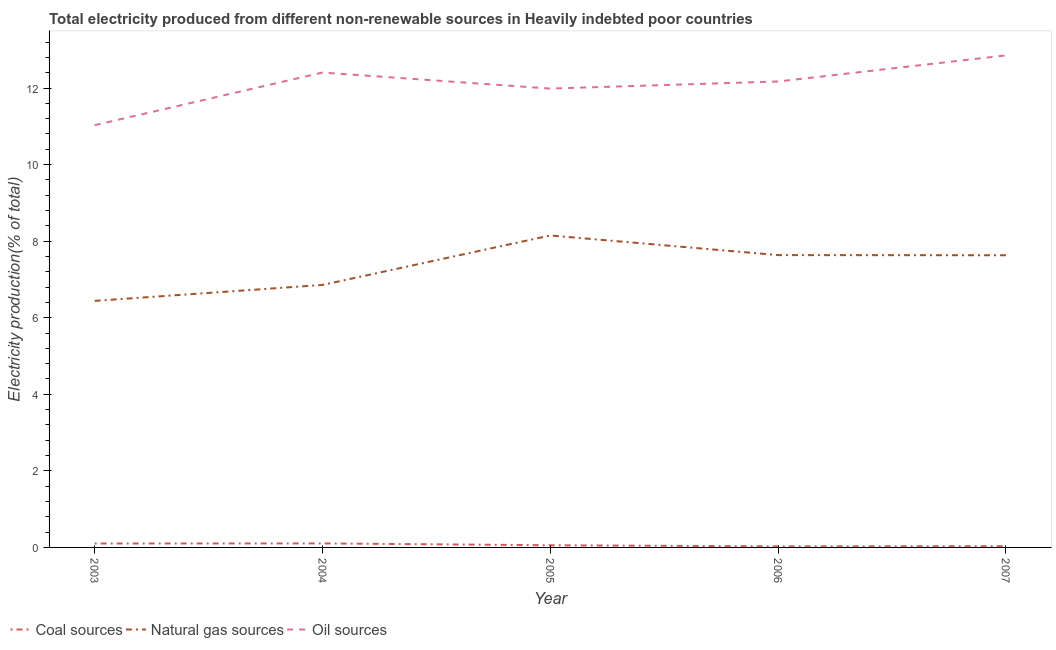What is the percentage of electricity produced by oil sources in 2004?
Give a very brief answer. 12.4. Across all years, what is the maximum percentage of electricity produced by oil sources?
Give a very brief answer. 12.85. Across all years, what is the minimum percentage of electricity produced by oil sources?
Provide a succinct answer. 11.03. In which year was the percentage of electricity produced by coal maximum?
Keep it short and to the point. 2004. In which year was the percentage of electricity produced by coal minimum?
Your response must be concise. 2006. What is the total percentage of electricity produced by coal in the graph?
Offer a terse response. 0.32. What is the difference between the percentage of electricity produced by coal in 2004 and that in 2007?
Offer a terse response. 0.07. What is the difference between the percentage of electricity produced by oil sources in 2007 and the percentage of electricity produced by natural gas in 2006?
Your response must be concise. 5.22. What is the average percentage of electricity produced by natural gas per year?
Your answer should be compact. 7.34. In the year 2006, what is the difference between the percentage of electricity produced by natural gas and percentage of electricity produced by oil sources?
Provide a short and direct response. -4.53. In how many years, is the percentage of electricity produced by coal greater than 9.2 %?
Offer a terse response. 0. What is the ratio of the percentage of electricity produced by natural gas in 2005 to that in 2007?
Provide a short and direct response. 1.07. What is the difference between the highest and the second highest percentage of electricity produced by coal?
Keep it short and to the point. 0. What is the difference between the highest and the lowest percentage of electricity produced by oil sources?
Provide a short and direct response. 1.82. Is the sum of the percentage of electricity produced by coal in 2003 and 2006 greater than the maximum percentage of electricity produced by oil sources across all years?
Give a very brief answer. No. Is it the case that in every year, the sum of the percentage of electricity produced by coal and percentage of electricity produced by natural gas is greater than the percentage of electricity produced by oil sources?
Your answer should be very brief. No. Does the percentage of electricity produced by natural gas monotonically increase over the years?
Your response must be concise. No. How many years are there in the graph?
Provide a succinct answer. 5. Are the values on the major ticks of Y-axis written in scientific E-notation?
Keep it short and to the point. No. Where does the legend appear in the graph?
Your response must be concise. Bottom left. How many legend labels are there?
Offer a very short reply. 3. What is the title of the graph?
Your response must be concise. Total electricity produced from different non-renewable sources in Heavily indebted poor countries. Does "Unpaid family workers" appear as one of the legend labels in the graph?
Your response must be concise. No. What is the Electricity production(% of total) of Coal sources in 2003?
Your answer should be compact. 0.1. What is the Electricity production(% of total) of Natural gas sources in 2003?
Provide a short and direct response. 6.44. What is the Electricity production(% of total) in Oil sources in 2003?
Provide a short and direct response. 11.03. What is the Electricity production(% of total) in Coal sources in 2004?
Provide a short and direct response. 0.11. What is the Electricity production(% of total) in Natural gas sources in 2004?
Offer a very short reply. 6.86. What is the Electricity production(% of total) in Oil sources in 2004?
Provide a succinct answer. 12.4. What is the Electricity production(% of total) of Coal sources in 2005?
Provide a short and direct response. 0.06. What is the Electricity production(% of total) of Natural gas sources in 2005?
Ensure brevity in your answer.  8.15. What is the Electricity production(% of total) of Oil sources in 2005?
Ensure brevity in your answer.  11.98. What is the Electricity production(% of total) in Coal sources in 2006?
Your answer should be very brief. 0.03. What is the Electricity production(% of total) of Natural gas sources in 2006?
Offer a very short reply. 7.64. What is the Electricity production(% of total) of Oil sources in 2006?
Offer a very short reply. 12.17. What is the Electricity production(% of total) of Coal sources in 2007?
Make the answer very short. 0.03. What is the Electricity production(% of total) in Natural gas sources in 2007?
Your response must be concise. 7.63. What is the Electricity production(% of total) of Oil sources in 2007?
Provide a short and direct response. 12.85. Across all years, what is the maximum Electricity production(% of total) of Coal sources?
Offer a very short reply. 0.11. Across all years, what is the maximum Electricity production(% of total) of Natural gas sources?
Your answer should be compact. 8.15. Across all years, what is the maximum Electricity production(% of total) of Oil sources?
Your response must be concise. 12.85. Across all years, what is the minimum Electricity production(% of total) in Coal sources?
Offer a very short reply. 0.03. Across all years, what is the minimum Electricity production(% of total) of Natural gas sources?
Offer a terse response. 6.44. Across all years, what is the minimum Electricity production(% of total) in Oil sources?
Give a very brief answer. 11.03. What is the total Electricity production(% of total) of Coal sources in the graph?
Provide a succinct answer. 0.32. What is the total Electricity production(% of total) of Natural gas sources in the graph?
Your answer should be very brief. 36.71. What is the total Electricity production(% of total) in Oil sources in the graph?
Offer a terse response. 60.44. What is the difference between the Electricity production(% of total) of Coal sources in 2003 and that in 2004?
Ensure brevity in your answer.  -0. What is the difference between the Electricity production(% of total) of Natural gas sources in 2003 and that in 2004?
Your answer should be very brief. -0.42. What is the difference between the Electricity production(% of total) in Oil sources in 2003 and that in 2004?
Provide a succinct answer. -1.38. What is the difference between the Electricity production(% of total) in Coal sources in 2003 and that in 2005?
Provide a succinct answer. 0.05. What is the difference between the Electricity production(% of total) in Natural gas sources in 2003 and that in 2005?
Provide a succinct answer. -1.71. What is the difference between the Electricity production(% of total) in Oil sources in 2003 and that in 2005?
Make the answer very short. -0.96. What is the difference between the Electricity production(% of total) in Coal sources in 2003 and that in 2006?
Your answer should be very brief. 0.07. What is the difference between the Electricity production(% of total) in Natural gas sources in 2003 and that in 2006?
Ensure brevity in your answer.  -1.2. What is the difference between the Electricity production(% of total) in Oil sources in 2003 and that in 2006?
Keep it short and to the point. -1.14. What is the difference between the Electricity production(% of total) of Coal sources in 2003 and that in 2007?
Your response must be concise. 0.07. What is the difference between the Electricity production(% of total) of Natural gas sources in 2003 and that in 2007?
Keep it short and to the point. -1.19. What is the difference between the Electricity production(% of total) in Oil sources in 2003 and that in 2007?
Your answer should be compact. -1.82. What is the difference between the Electricity production(% of total) of Coal sources in 2004 and that in 2005?
Keep it short and to the point. 0.05. What is the difference between the Electricity production(% of total) of Natural gas sources in 2004 and that in 2005?
Provide a short and direct response. -1.29. What is the difference between the Electricity production(% of total) of Oil sources in 2004 and that in 2005?
Your answer should be compact. 0.42. What is the difference between the Electricity production(% of total) of Coal sources in 2004 and that in 2006?
Your response must be concise. 0.08. What is the difference between the Electricity production(% of total) of Natural gas sources in 2004 and that in 2006?
Make the answer very short. -0.78. What is the difference between the Electricity production(% of total) of Oil sources in 2004 and that in 2006?
Your response must be concise. 0.23. What is the difference between the Electricity production(% of total) of Coal sources in 2004 and that in 2007?
Make the answer very short. 0.07. What is the difference between the Electricity production(% of total) of Natural gas sources in 2004 and that in 2007?
Your response must be concise. -0.78. What is the difference between the Electricity production(% of total) of Oil sources in 2004 and that in 2007?
Keep it short and to the point. -0.45. What is the difference between the Electricity production(% of total) of Coal sources in 2005 and that in 2006?
Offer a very short reply. 0.03. What is the difference between the Electricity production(% of total) of Natural gas sources in 2005 and that in 2006?
Your answer should be compact. 0.51. What is the difference between the Electricity production(% of total) in Oil sources in 2005 and that in 2006?
Your answer should be very brief. -0.19. What is the difference between the Electricity production(% of total) of Coal sources in 2005 and that in 2007?
Provide a short and direct response. 0.02. What is the difference between the Electricity production(% of total) of Natural gas sources in 2005 and that in 2007?
Provide a short and direct response. 0.52. What is the difference between the Electricity production(% of total) in Oil sources in 2005 and that in 2007?
Ensure brevity in your answer.  -0.87. What is the difference between the Electricity production(% of total) in Coal sources in 2006 and that in 2007?
Keep it short and to the point. -0. What is the difference between the Electricity production(% of total) of Natural gas sources in 2006 and that in 2007?
Keep it short and to the point. 0. What is the difference between the Electricity production(% of total) in Oil sources in 2006 and that in 2007?
Your response must be concise. -0.68. What is the difference between the Electricity production(% of total) of Coal sources in 2003 and the Electricity production(% of total) of Natural gas sources in 2004?
Provide a succinct answer. -6.75. What is the difference between the Electricity production(% of total) in Coal sources in 2003 and the Electricity production(% of total) in Oil sources in 2004?
Your answer should be compact. -12.3. What is the difference between the Electricity production(% of total) of Natural gas sources in 2003 and the Electricity production(% of total) of Oil sources in 2004?
Give a very brief answer. -5.96. What is the difference between the Electricity production(% of total) of Coal sources in 2003 and the Electricity production(% of total) of Natural gas sources in 2005?
Provide a succinct answer. -8.05. What is the difference between the Electricity production(% of total) in Coal sources in 2003 and the Electricity production(% of total) in Oil sources in 2005?
Offer a terse response. -11.88. What is the difference between the Electricity production(% of total) of Natural gas sources in 2003 and the Electricity production(% of total) of Oil sources in 2005?
Your answer should be compact. -5.55. What is the difference between the Electricity production(% of total) of Coal sources in 2003 and the Electricity production(% of total) of Natural gas sources in 2006?
Give a very brief answer. -7.53. What is the difference between the Electricity production(% of total) in Coal sources in 2003 and the Electricity production(% of total) in Oil sources in 2006?
Offer a terse response. -12.07. What is the difference between the Electricity production(% of total) of Natural gas sources in 2003 and the Electricity production(% of total) of Oil sources in 2006?
Keep it short and to the point. -5.73. What is the difference between the Electricity production(% of total) of Coal sources in 2003 and the Electricity production(% of total) of Natural gas sources in 2007?
Offer a terse response. -7.53. What is the difference between the Electricity production(% of total) in Coal sources in 2003 and the Electricity production(% of total) in Oil sources in 2007?
Ensure brevity in your answer.  -12.75. What is the difference between the Electricity production(% of total) of Natural gas sources in 2003 and the Electricity production(% of total) of Oil sources in 2007?
Keep it short and to the point. -6.41. What is the difference between the Electricity production(% of total) in Coal sources in 2004 and the Electricity production(% of total) in Natural gas sources in 2005?
Provide a short and direct response. -8.04. What is the difference between the Electricity production(% of total) of Coal sources in 2004 and the Electricity production(% of total) of Oil sources in 2005?
Offer a very short reply. -11.88. What is the difference between the Electricity production(% of total) of Natural gas sources in 2004 and the Electricity production(% of total) of Oil sources in 2005?
Give a very brief answer. -5.13. What is the difference between the Electricity production(% of total) of Coal sources in 2004 and the Electricity production(% of total) of Natural gas sources in 2006?
Your response must be concise. -7.53. What is the difference between the Electricity production(% of total) of Coal sources in 2004 and the Electricity production(% of total) of Oil sources in 2006?
Offer a very short reply. -12.07. What is the difference between the Electricity production(% of total) of Natural gas sources in 2004 and the Electricity production(% of total) of Oil sources in 2006?
Make the answer very short. -5.31. What is the difference between the Electricity production(% of total) in Coal sources in 2004 and the Electricity production(% of total) in Natural gas sources in 2007?
Offer a terse response. -7.53. What is the difference between the Electricity production(% of total) of Coal sources in 2004 and the Electricity production(% of total) of Oil sources in 2007?
Your answer should be very brief. -12.75. What is the difference between the Electricity production(% of total) of Natural gas sources in 2004 and the Electricity production(% of total) of Oil sources in 2007?
Provide a short and direct response. -6. What is the difference between the Electricity production(% of total) of Coal sources in 2005 and the Electricity production(% of total) of Natural gas sources in 2006?
Ensure brevity in your answer.  -7.58. What is the difference between the Electricity production(% of total) in Coal sources in 2005 and the Electricity production(% of total) in Oil sources in 2006?
Provide a succinct answer. -12.11. What is the difference between the Electricity production(% of total) in Natural gas sources in 2005 and the Electricity production(% of total) in Oil sources in 2006?
Provide a succinct answer. -4.02. What is the difference between the Electricity production(% of total) in Coal sources in 2005 and the Electricity production(% of total) in Natural gas sources in 2007?
Give a very brief answer. -7.58. What is the difference between the Electricity production(% of total) of Coal sources in 2005 and the Electricity production(% of total) of Oil sources in 2007?
Provide a succinct answer. -12.8. What is the difference between the Electricity production(% of total) in Natural gas sources in 2005 and the Electricity production(% of total) in Oil sources in 2007?
Provide a short and direct response. -4.7. What is the difference between the Electricity production(% of total) in Coal sources in 2006 and the Electricity production(% of total) in Natural gas sources in 2007?
Provide a succinct answer. -7.6. What is the difference between the Electricity production(% of total) of Coal sources in 2006 and the Electricity production(% of total) of Oil sources in 2007?
Your answer should be very brief. -12.82. What is the difference between the Electricity production(% of total) of Natural gas sources in 2006 and the Electricity production(% of total) of Oil sources in 2007?
Offer a terse response. -5.22. What is the average Electricity production(% of total) in Coal sources per year?
Your answer should be very brief. 0.06. What is the average Electricity production(% of total) of Natural gas sources per year?
Your answer should be compact. 7.34. What is the average Electricity production(% of total) of Oil sources per year?
Make the answer very short. 12.09. In the year 2003, what is the difference between the Electricity production(% of total) in Coal sources and Electricity production(% of total) in Natural gas sources?
Make the answer very short. -6.34. In the year 2003, what is the difference between the Electricity production(% of total) in Coal sources and Electricity production(% of total) in Oil sources?
Your response must be concise. -10.93. In the year 2003, what is the difference between the Electricity production(% of total) in Natural gas sources and Electricity production(% of total) in Oil sources?
Offer a terse response. -4.59. In the year 2004, what is the difference between the Electricity production(% of total) of Coal sources and Electricity production(% of total) of Natural gas sources?
Offer a terse response. -6.75. In the year 2004, what is the difference between the Electricity production(% of total) of Coal sources and Electricity production(% of total) of Oil sources?
Keep it short and to the point. -12.3. In the year 2004, what is the difference between the Electricity production(% of total) of Natural gas sources and Electricity production(% of total) of Oil sources?
Offer a very short reply. -5.55. In the year 2005, what is the difference between the Electricity production(% of total) of Coal sources and Electricity production(% of total) of Natural gas sources?
Make the answer very short. -8.09. In the year 2005, what is the difference between the Electricity production(% of total) in Coal sources and Electricity production(% of total) in Oil sources?
Ensure brevity in your answer.  -11.93. In the year 2005, what is the difference between the Electricity production(% of total) in Natural gas sources and Electricity production(% of total) in Oil sources?
Provide a succinct answer. -3.84. In the year 2006, what is the difference between the Electricity production(% of total) of Coal sources and Electricity production(% of total) of Natural gas sources?
Ensure brevity in your answer.  -7.61. In the year 2006, what is the difference between the Electricity production(% of total) of Coal sources and Electricity production(% of total) of Oil sources?
Provide a succinct answer. -12.14. In the year 2006, what is the difference between the Electricity production(% of total) in Natural gas sources and Electricity production(% of total) in Oil sources?
Your answer should be very brief. -4.53. In the year 2007, what is the difference between the Electricity production(% of total) of Coal sources and Electricity production(% of total) of Natural gas sources?
Your answer should be very brief. -7.6. In the year 2007, what is the difference between the Electricity production(% of total) in Coal sources and Electricity production(% of total) in Oil sources?
Keep it short and to the point. -12.82. In the year 2007, what is the difference between the Electricity production(% of total) of Natural gas sources and Electricity production(% of total) of Oil sources?
Offer a very short reply. -5.22. What is the ratio of the Electricity production(% of total) in Coal sources in 2003 to that in 2004?
Provide a short and direct response. 0.98. What is the ratio of the Electricity production(% of total) of Natural gas sources in 2003 to that in 2004?
Your response must be concise. 0.94. What is the ratio of the Electricity production(% of total) in Oil sources in 2003 to that in 2004?
Your answer should be compact. 0.89. What is the ratio of the Electricity production(% of total) in Coal sources in 2003 to that in 2005?
Offer a very short reply. 1.82. What is the ratio of the Electricity production(% of total) of Natural gas sources in 2003 to that in 2005?
Keep it short and to the point. 0.79. What is the ratio of the Electricity production(% of total) of Oil sources in 2003 to that in 2005?
Keep it short and to the point. 0.92. What is the ratio of the Electricity production(% of total) of Coal sources in 2003 to that in 2006?
Your answer should be very brief. 3.66. What is the ratio of the Electricity production(% of total) in Natural gas sources in 2003 to that in 2006?
Your answer should be compact. 0.84. What is the ratio of the Electricity production(% of total) of Oil sources in 2003 to that in 2006?
Your answer should be compact. 0.91. What is the ratio of the Electricity production(% of total) in Coal sources in 2003 to that in 2007?
Provide a succinct answer. 3.17. What is the ratio of the Electricity production(% of total) of Natural gas sources in 2003 to that in 2007?
Provide a succinct answer. 0.84. What is the ratio of the Electricity production(% of total) of Oil sources in 2003 to that in 2007?
Keep it short and to the point. 0.86. What is the ratio of the Electricity production(% of total) in Coal sources in 2004 to that in 2005?
Provide a short and direct response. 1.86. What is the ratio of the Electricity production(% of total) in Natural gas sources in 2004 to that in 2005?
Ensure brevity in your answer.  0.84. What is the ratio of the Electricity production(% of total) of Oil sources in 2004 to that in 2005?
Your answer should be very brief. 1.03. What is the ratio of the Electricity production(% of total) in Coal sources in 2004 to that in 2006?
Your answer should be compact. 3.75. What is the ratio of the Electricity production(% of total) of Natural gas sources in 2004 to that in 2006?
Provide a short and direct response. 0.9. What is the ratio of the Electricity production(% of total) of Oil sources in 2004 to that in 2006?
Offer a very short reply. 1.02. What is the ratio of the Electricity production(% of total) in Coal sources in 2004 to that in 2007?
Your answer should be compact. 3.25. What is the ratio of the Electricity production(% of total) of Natural gas sources in 2004 to that in 2007?
Keep it short and to the point. 0.9. What is the ratio of the Electricity production(% of total) in Oil sources in 2004 to that in 2007?
Offer a terse response. 0.97. What is the ratio of the Electricity production(% of total) of Coal sources in 2005 to that in 2006?
Ensure brevity in your answer.  2.02. What is the ratio of the Electricity production(% of total) of Natural gas sources in 2005 to that in 2006?
Your answer should be compact. 1.07. What is the ratio of the Electricity production(% of total) of Oil sources in 2005 to that in 2006?
Provide a short and direct response. 0.98. What is the ratio of the Electricity production(% of total) in Coal sources in 2005 to that in 2007?
Offer a terse response. 1.75. What is the ratio of the Electricity production(% of total) in Natural gas sources in 2005 to that in 2007?
Make the answer very short. 1.07. What is the ratio of the Electricity production(% of total) of Oil sources in 2005 to that in 2007?
Give a very brief answer. 0.93. What is the ratio of the Electricity production(% of total) of Coal sources in 2006 to that in 2007?
Give a very brief answer. 0.87. What is the ratio of the Electricity production(% of total) of Oil sources in 2006 to that in 2007?
Ensure brevity in your answer.  0.95. What is the difference between the highest and the second highest Electricity production(% of total) in Coal sources?
Give a very brief answer. 0. What is the difference between the highest and the second highest Electricity production(% of total) of Natural gas sources?
Your response must be concise. 0.51. What is the difference between the highest and the second highest Electricity production(% of total) in Oil sources?
Your answer should be very brief. 0.45. What is the difference between the highest and the lowest Electricity production(% of total) in Coal sources?
Keep it short and to the point. 0.08. What is the difference between the highest and the lowest Electricity production(% of total) of Natural gas sources?
Your answer should be compact. 1.71. What is the difference between the highest and the lowest Electricity production(% of total) of Oil sources?
Offer a very short reply. 1.82. 